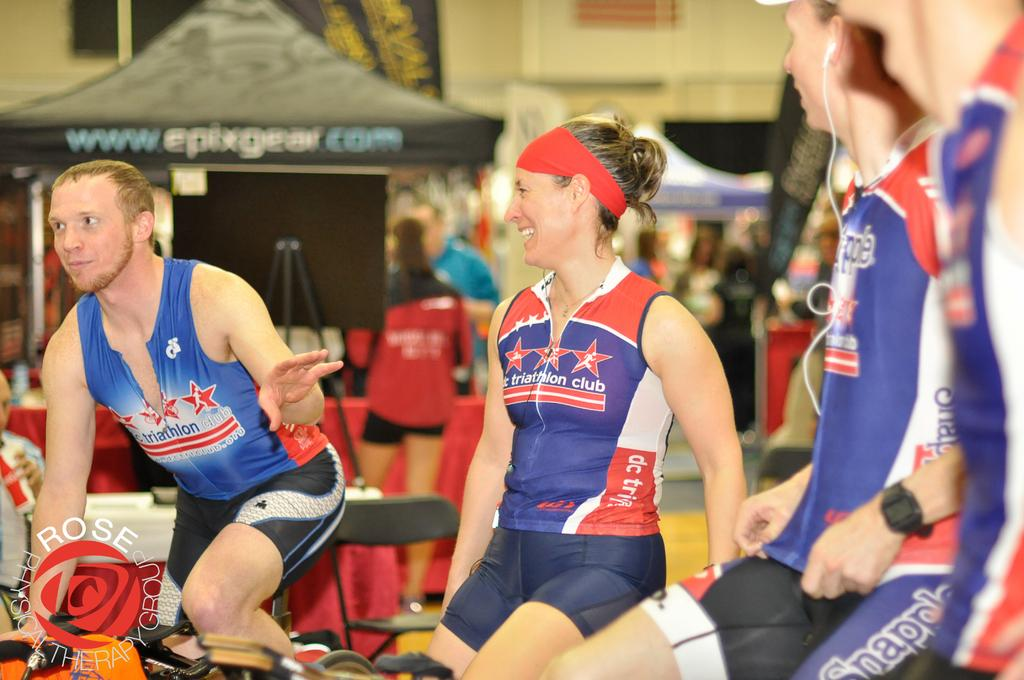<image>
Provide a brief description of the given image. Some men and women are riding exercise bikes and wearing workout clothes that say Triathlon. 